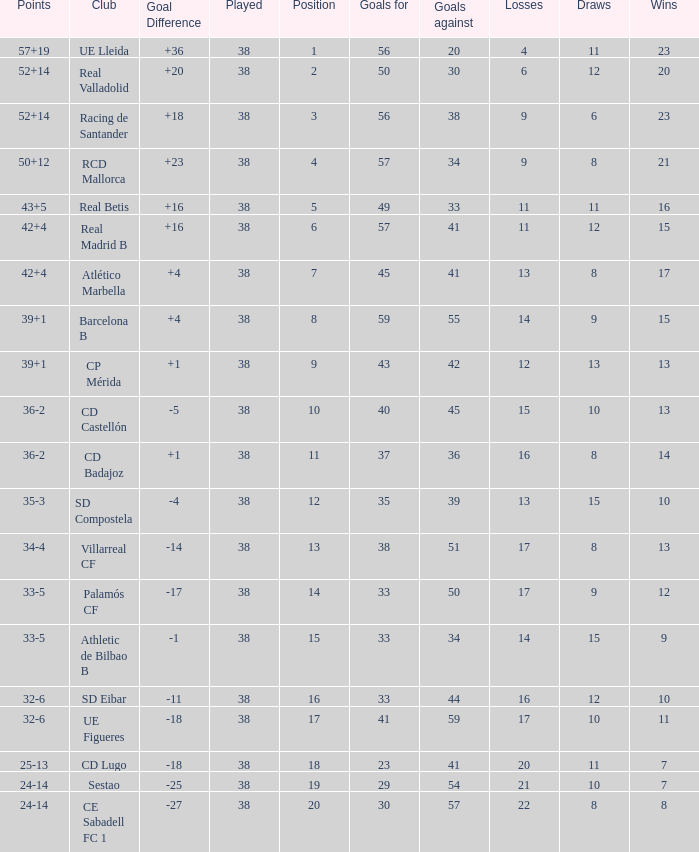What is the highest number played with a goal difference less than -27? None. 